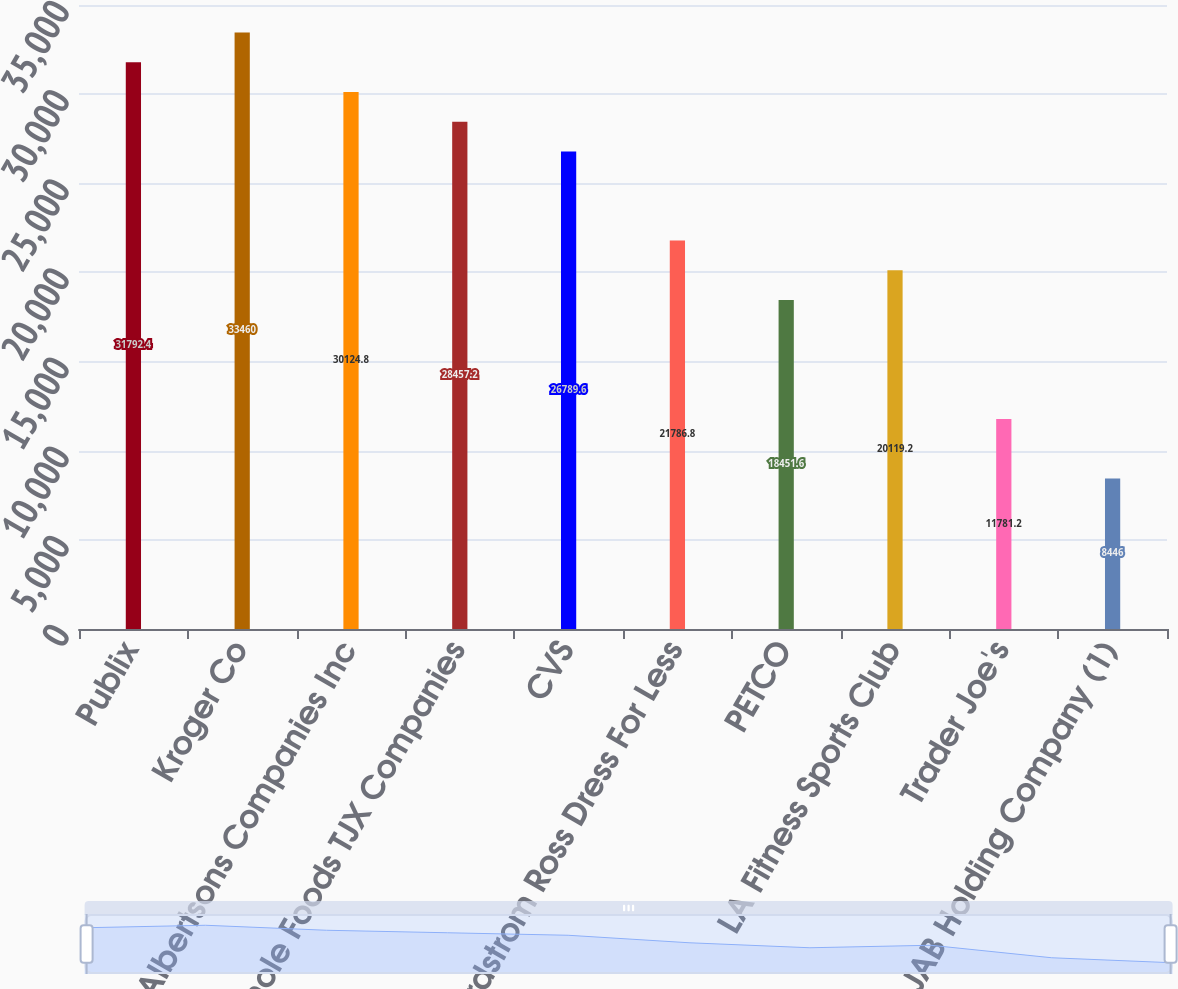<chart> <loc_0><loc_0><loc_500><loc_500><bar_chart><fcel>Publix<fcel>Kroger Co<fcel>Albertsons Companies Inc<fcel>Whole Foods TJX Companies<fcel>CVS<fcel>Nordstrom Ross Dress For Less<fcel>PETCO<fcel>LA Fitness Sports Club<fcel>Trader Joe's<fcel>JAB Holding Company (1)<nl><fcel>31792.4<fcel>33460<fcel>30124.8<fcel>28457.2<fcel>26789.6<fcel>21786.8<fcel>18451.6<fcel>20119.2<fcel>11781.2<fcel>8446<nl></chart> 